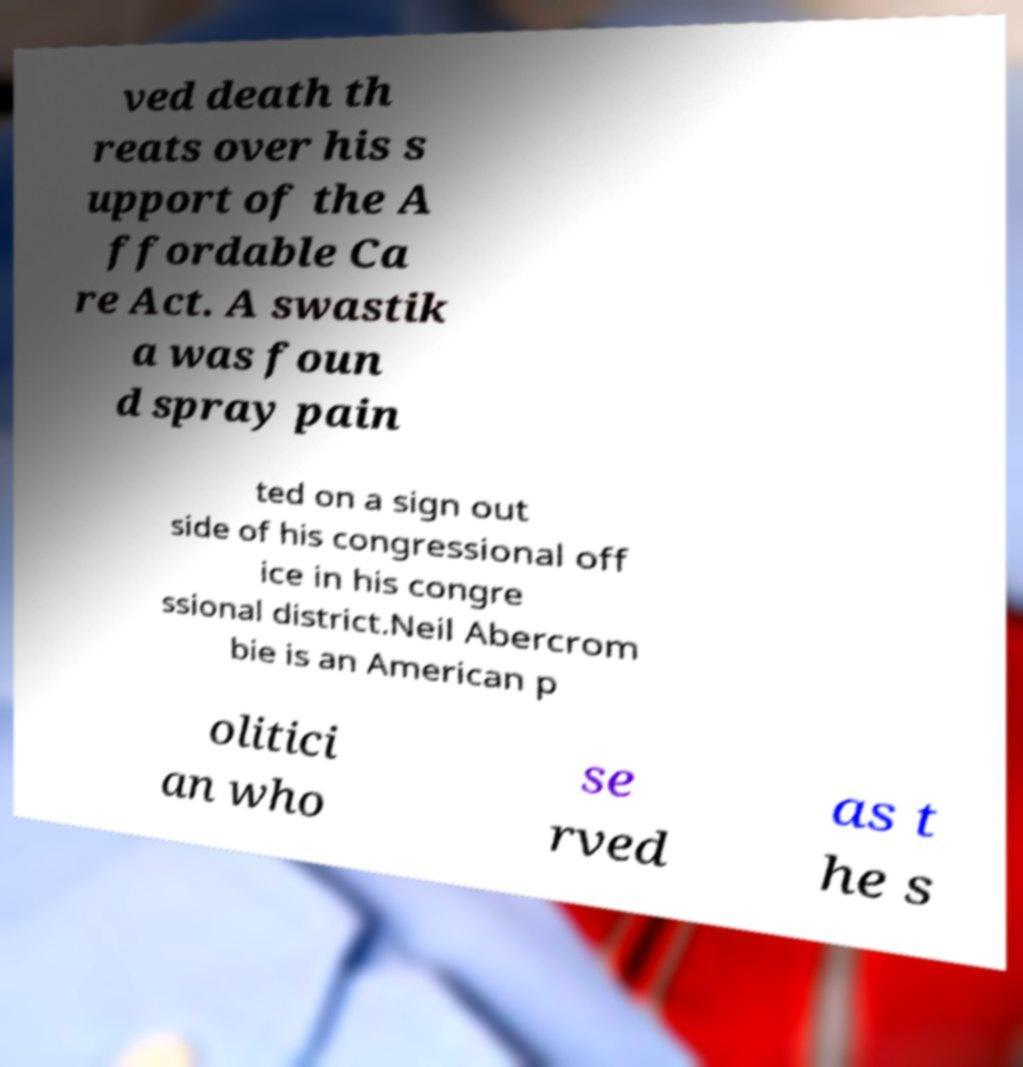Please read and relay the text visible in this image. What does it say? ved death th reats over his s upport of the A ffordable Ca re Act. A swastik a was foun d spray pain ted on a sign out side of his congressional off ice in his congre ssional district.Neil Abercrom bie is an American p olitici an who se rved as t he s 